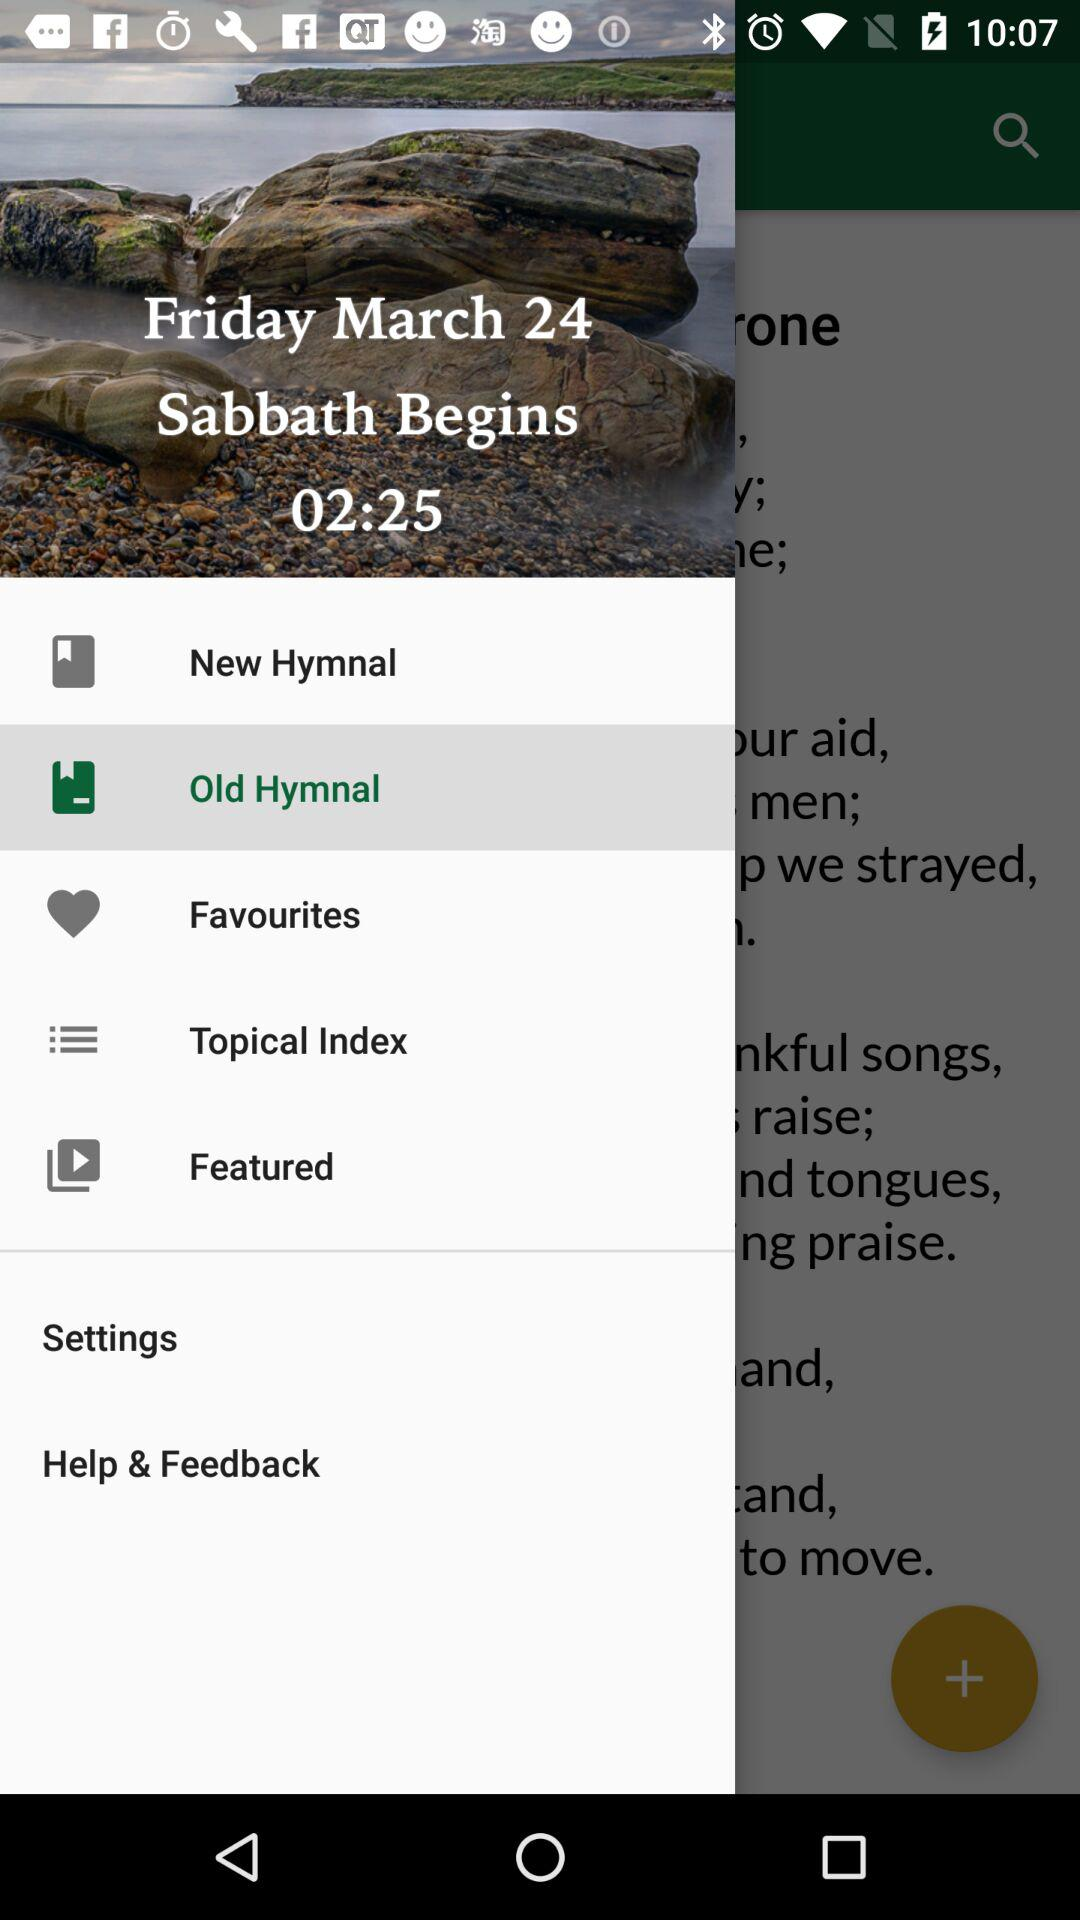On which day does the "Sabbath" begin? The "Sabbath" begins on Friday. 